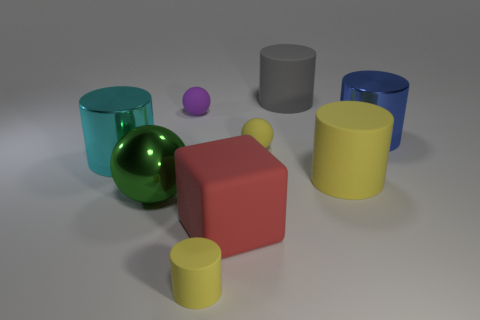How big is the blue metallic object?
Your response must be concise. Large. There is a metal thing in front of the big metal cylinder on the left side of the red matte block; how many big cyan cylinders are in front of it?
Offer a terse response. 0. There is a tiny yellow matte object that is to the left of the large matte object to the left of the gray object; what shape is it?
Provide a succinct answer. Cylinder. There is a purple rubber thing that is the same shape as the big green object; what is its size?
Provide a short and direct response. Small. What is the color of the tiny sphere in front of the blue object?
Your response must be concise. Yellow. The cylinder on the left side of the matte cylinder in front of the red thing that is left of the big gray matte cylinder is made of what material?
Offer a terse response. Metal. There is a ball that is right of the tiny object that is in front of the red cube; what is its size?
Your answer should be compact. Small. There is another large matte thing that is the same shape as the big gray object; what is its color?
Your response must be concise. Yellow. What number of large spheres have the same color as the large block?
Offer a terse response. 0. Is the green shiny ball the same size as the cyan shiny cylinder?
Provide a short and direct response. Yes. 